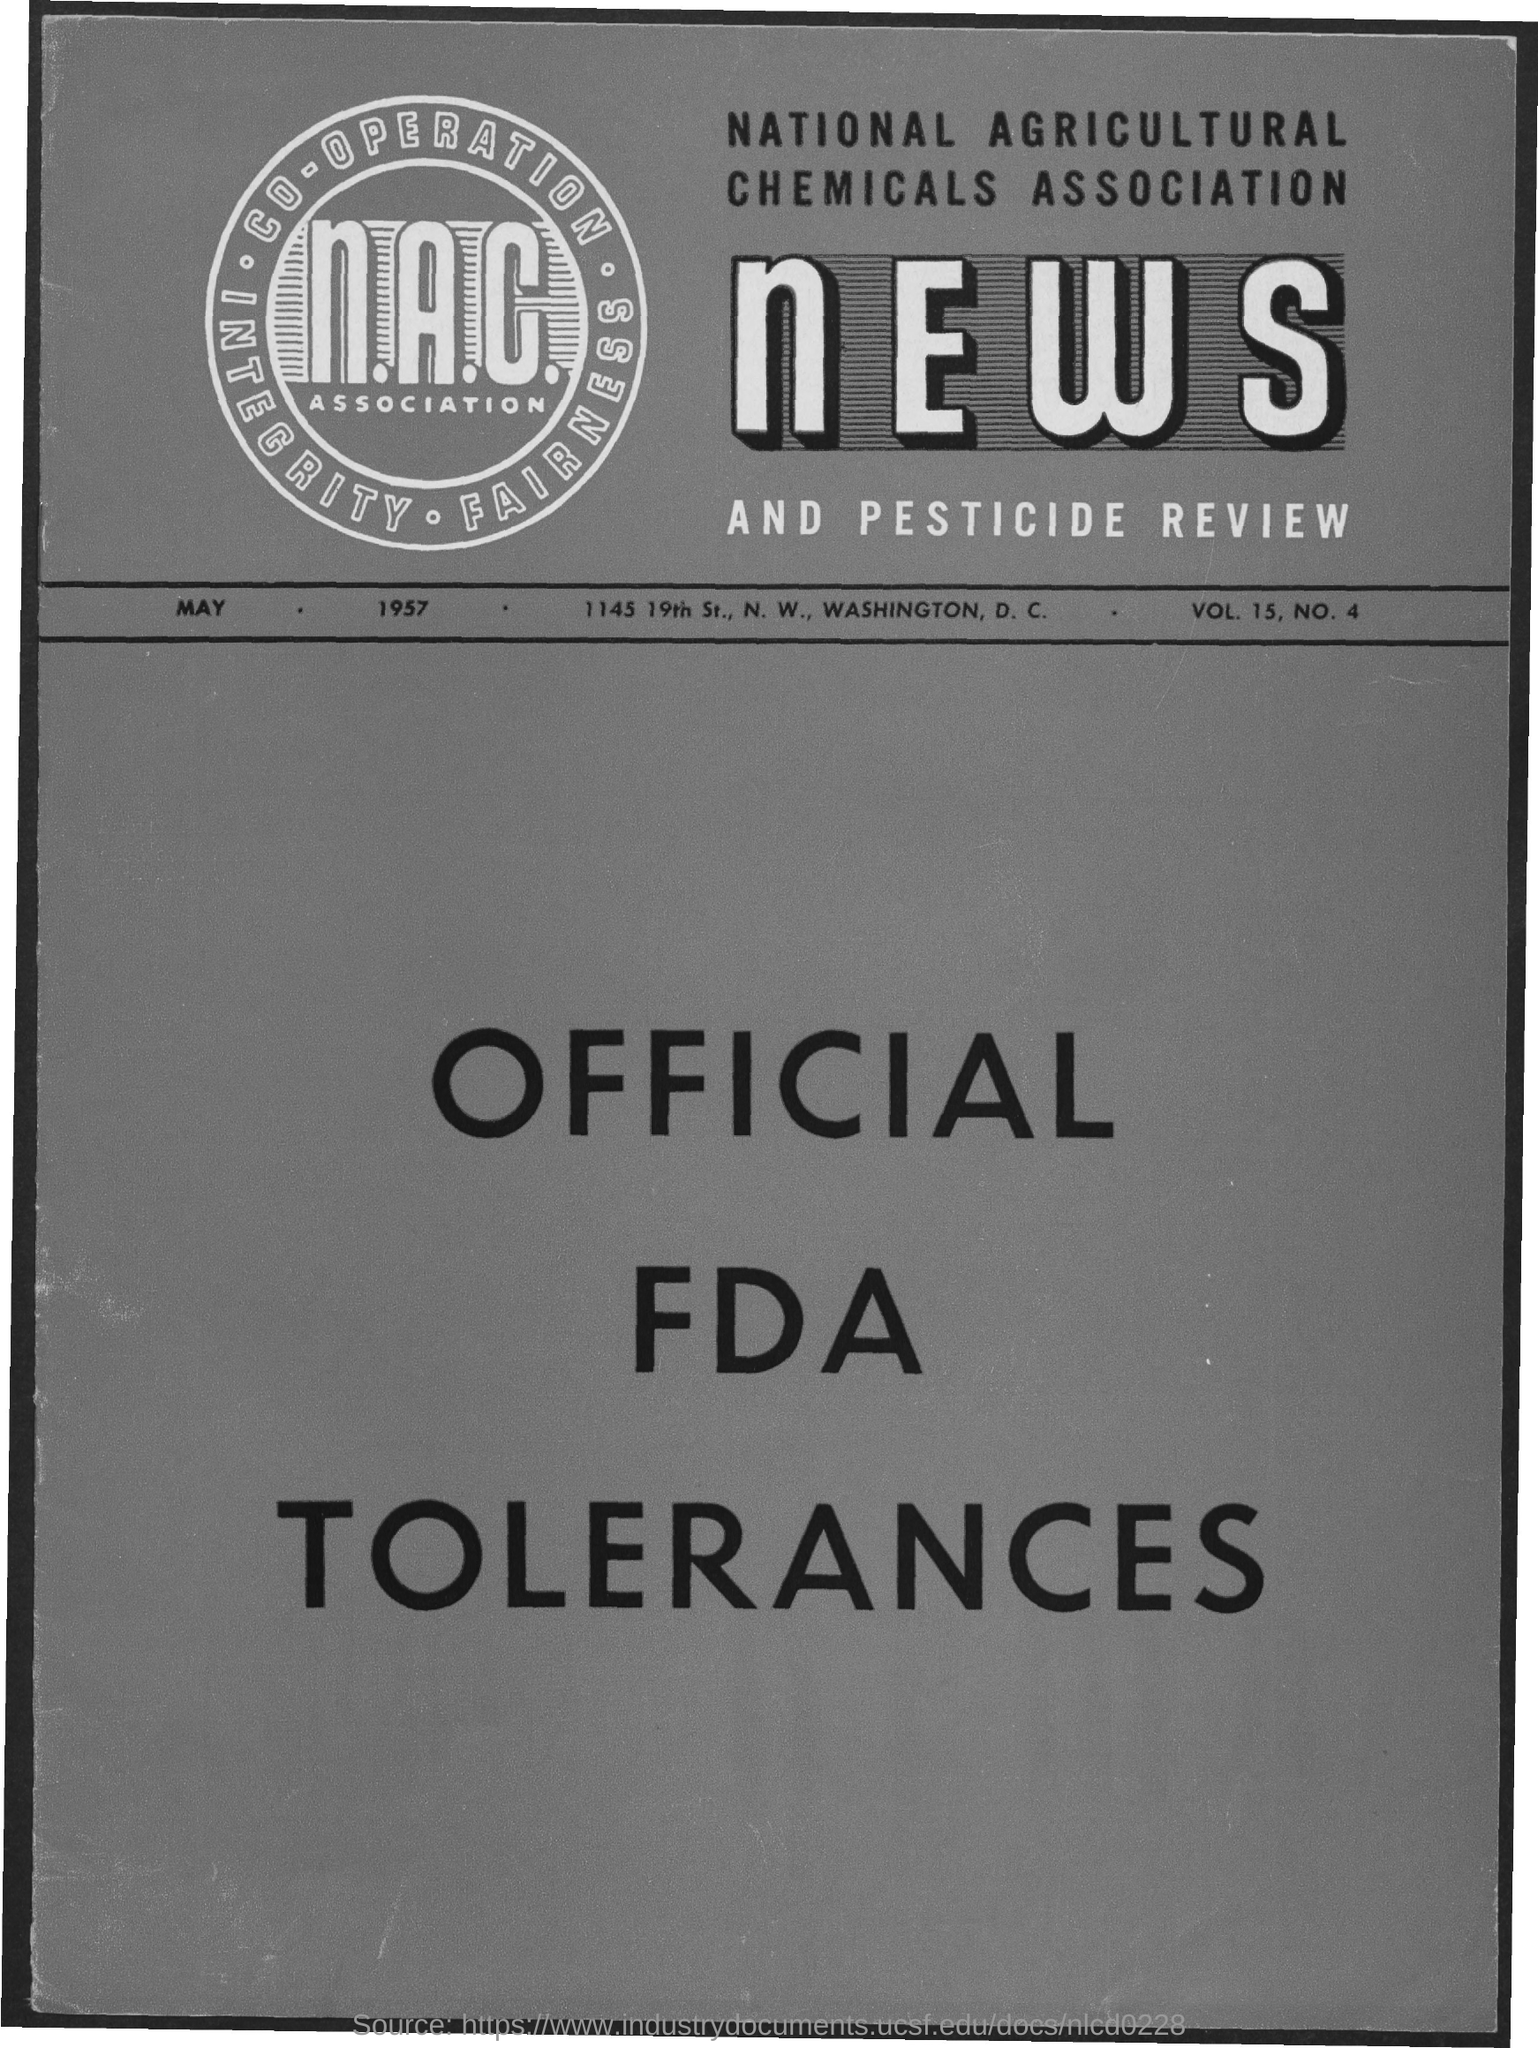Point out several critical features in this image. The National Agricultural Chemicals Association is the first title in the document. 